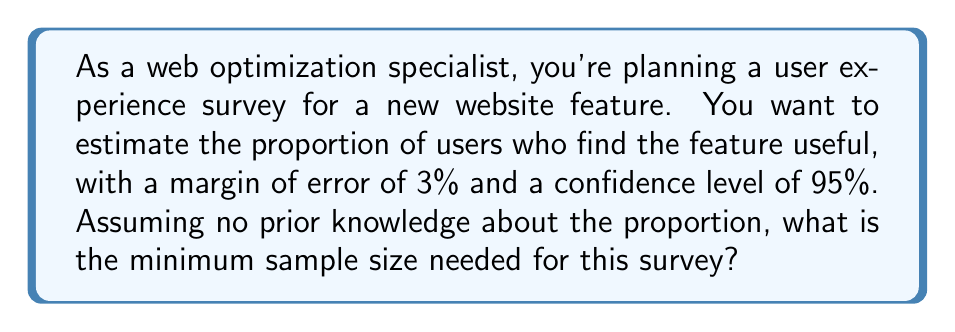What is the answer to this math problem? To determine the sample size for estimating a proportion with a specified margin of error and confidence level, we use the following formula:

$$ n = \frac{z^2 \cdot p(1-p)}{E^2} $$

Where:
- $n$ is the sample size
- $z$ is the z-score for the desired confidence level
- $p$ is the estimated proportion
- $E$ is the margin of error

Step 1: Determine the z-score for 95% confidence level
For a 95% confidence level, $z = 1.96$

Step 2: Set the margin of error
$E = 0.03$ (3% expressed as a decimal)

Step 3: Determine the value of $p$
Since we have no prior knowledge about the proportion, we use $p = 0.5$, which gives the most conservative (largest) sample size.

Step 4: Apply the formula
$$ n = \frac{1.96^2 \cdot 0.5(1-0.5)}{0.03^2} $$

$$ n = \frac{3.8416 \cdot 0.25}{0.0009} $$

$$ n = 1067.11 $$

Step 5: Round up to the nearest whole number
The minimum sample size needed is 1068.
Answer: 1068 